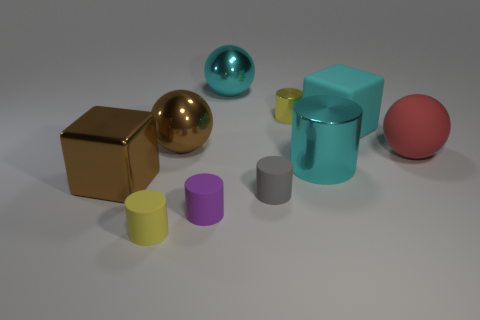What is the shape of the big red rubber object?
Give a very brief answer. Sphere. How big is the metal thing left of the small yellow cylinder that is in front of the brown shiny cube?
Make the answer very short. Large. What number of things are large blue metal cylinders or brown shiny objects?
Your answer should be compact. 2. Is the shape of the big cyan matte object the same as the large red object?
Offer a terse response. No. Is there a big cyan cylinder made of the same material as the brown ball?
Provide a succinct answer. Yes. Is there a big metal cylinder in front of the yellow object left of the gray object?
Your response must be concise. No. Is the size of the block that is right of the gray rubber cylinder the same as the purple matte cylinder?
Offer a terse response. No. The purple cylinder is what size?
Your response must be concise. Small. Are there any other big cylinders of the same color as the large metallic cylinder?
Your response must be concise. No. How many large objects are either shiny blocks or purple rubber cylinders?
Keep it short and to the point. 1. 